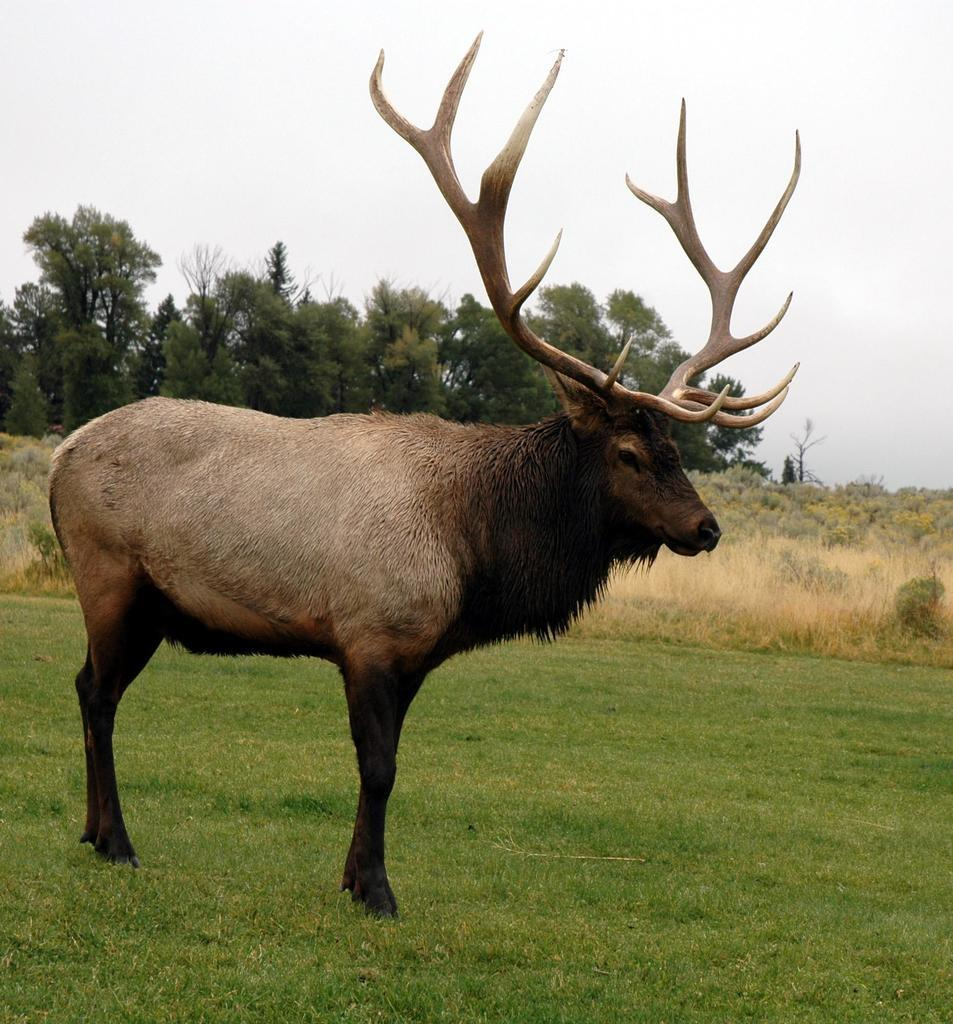What animal is present in the image? There is a reindeer in the image. Where is the reindeer located? The reindeer is standing on the ground. What can be seen in the background of the image? There is sky, trees, and plants visible in the background of the image. How many creatures are present in the image? There is only one creature present in the image, which is the reindeer. What type of stew is being prepared in the image? There is no stew or cooking activity present in the image. 